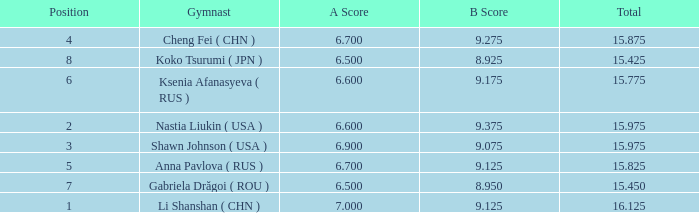What's the total that the position is less than 1? None. 